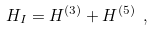Convert formula to latex. <formula><loc_0><loc_0><loc_500><loc_500>H _ { I } = H ^ { ( 3 ) } + H ^ { ( 5 ) } \ ,</formula> 